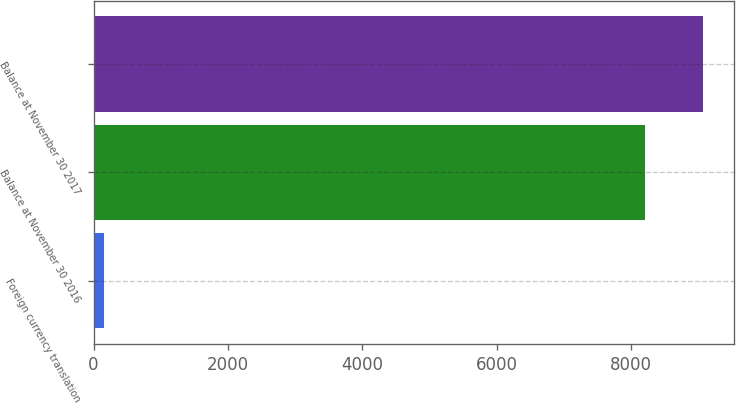Convert chart. <chart><loc_0><loc_0><loc_500><loc_500><bar_chart><fcel>Foreign currency translation<fcel>Balance at November 30 2016<fcel>Balance at November 30 2017<nl><fcel>153.1<fcel>8209.8<fcel>9072.34<nl></chart> 